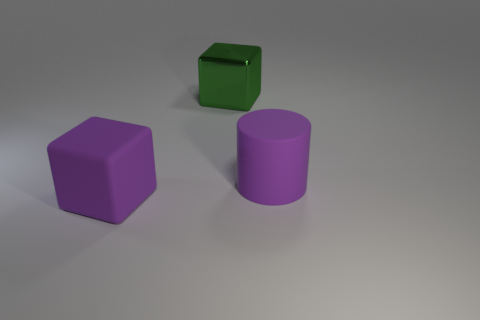Are there any other things that are the same material as the large green cube?
Provide a short and direct response. No. There is a metal cube that is the same size as the rubber block; what color is it?
Your answer should be compact. Green. There is a matte cylinder; does it have the same color as the large rubber object on the left side of the large green cube?
Keep it short and to the point. Yes. There is a cube behind the big purple rubber object that is to the right of the purple rubber cube; what is it made of?
Make the answer very short. Metal. How many big things are both in front of the large green thing and on the right side of the large purple matte block?
Give a very brief answer. 1. How many other objects are there of the same size as the green block?
Your answer should be compact. 2. There is a big object in front of the big purple cylinder; is it the same shape as the large green object that is left of the big purple matte cylinder?
Give a very brief answer. Yes. There is a metal thing; are there any matte things right of it?
Provide a succinct answer. Yes. There is a large matte object that is the same shape as the metal object; what is its color?
Provide a short and direct response. Purple. What is the material of the big object that is on the right side of the big shiny thing?
Make the answer very short. Rubber. 